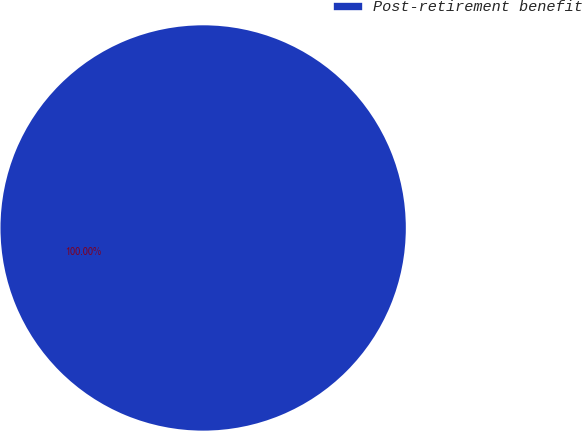<chart> <loc_0><loc_0><loc_500><loc_500><pie_chart><fcel>Post-retirement benefit<nl><fcel>100.0%<nl></chart> 